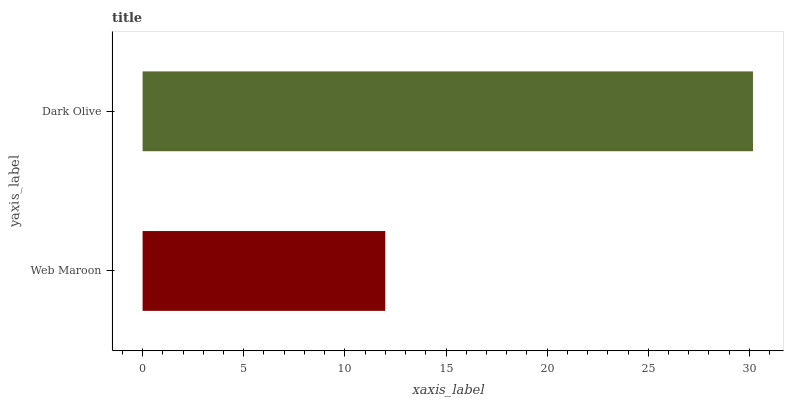Is Web Maroon the minimum?
Answer yes or no. Yes. Is Dark Olive the maximum?
Answer yes or no. Yes. Is Dark Olive the minimum?
Answer yes or no. No. Is Dark Olive greater than Web Maroon?
Answer yes or no. Yes. Is Web Maroon less than Dark Olive?
Answer yes or no. Yes. Is Web Maroon greater than Dark Olive?
Answer yes or no. No. Is Dark Olive less than Web Maroon?
Answer yes or no. No. Is Dark Olive the high median?
Answer yes or no. Yes. Is Web Maroon the low median?
Answer yes or no. Yes. Is Web Maroon the high median?
Answer yes or no. No. Is Dark Olive the low median?
Answer yes or no. No. 